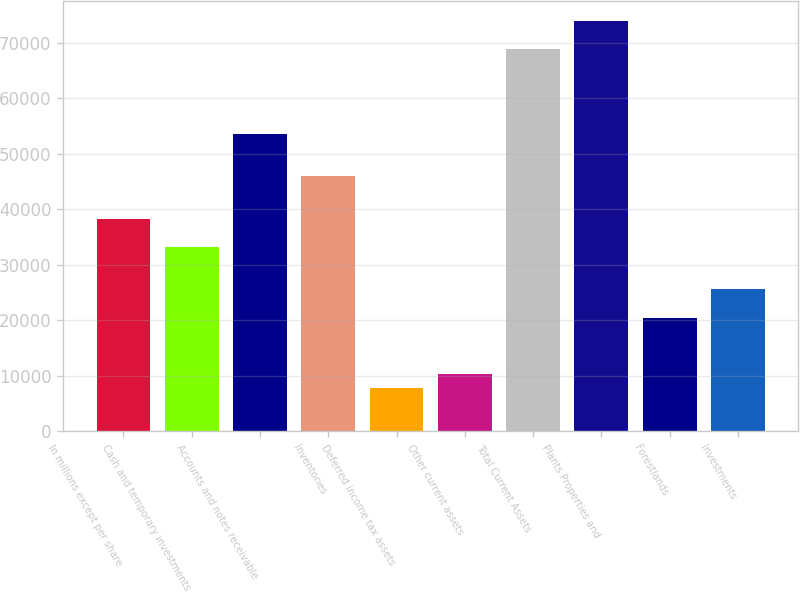Convert chart to OTSL. <chart><loc_0><loc_0><loc_500><loc_500><bar_chart><fcel>In millions except per share<fcel>Cash and temporary investments<fcel>Accounts and notes receivable<fcel>Inventories<fcel>Deferred income tax assets<fcel>Other current assets<fcel>Total Current Assets<fcel>Plants Properties and<fcel>Forestlands<fcel>Investments<nl><fcel>38277.5<fcel>33185.7<fcel>53552.9<fcel>45915.2<fcel>7726.7<fcel>10272.6<fcel>68828.3<fcel>73920.1<fcel>20456.2<fcel>25548<nl></chart> 